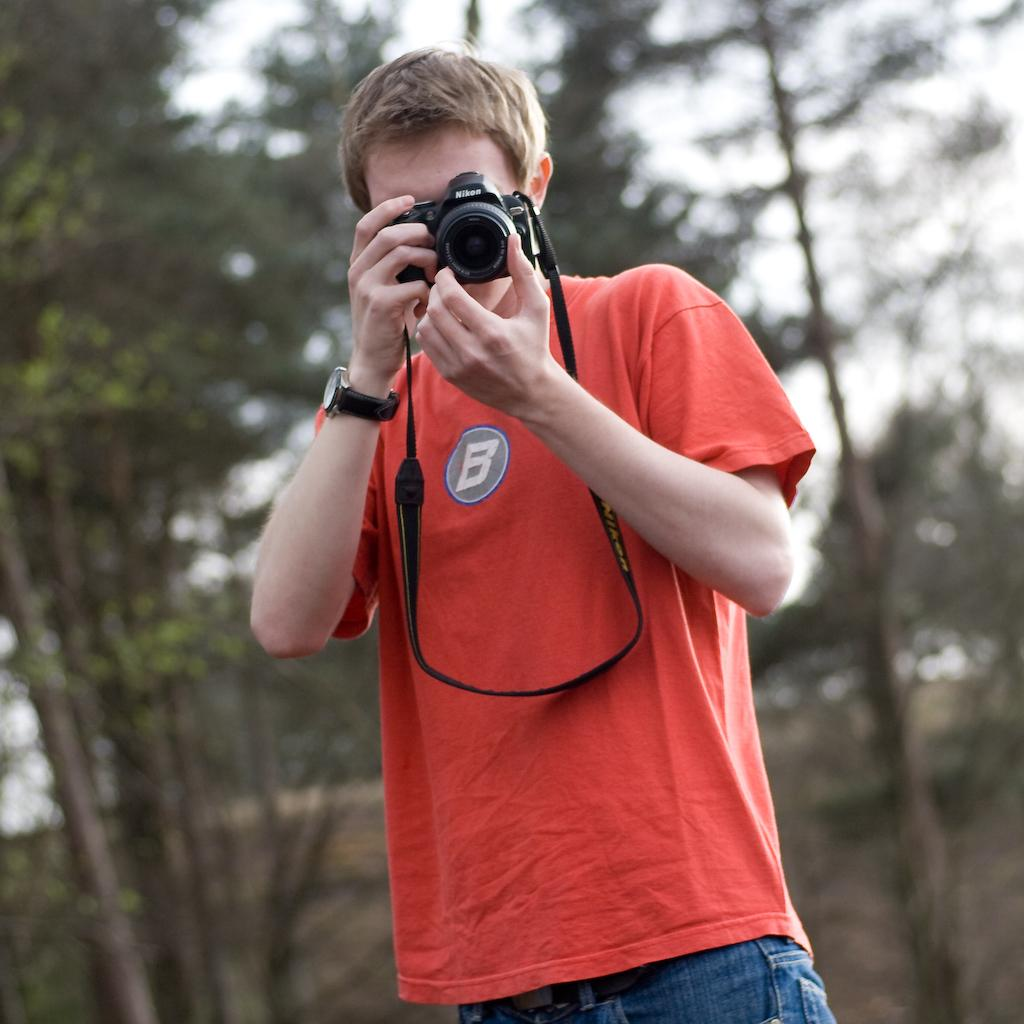Where was the image taken? The image was taken outside. Who is present in the image? There is a man in the image. What is the man wearing? The man is wearing an orange color shirt. What is the man holding in the image? The man is holding a camera. What accessory is the man wearing on his wrist? The man is wearing a watch. What can be seen in the background of the image? There are trees visible in the background of the image. What process is the man teaching at the school in the image? There is no school or teaching process present in the image; it features a man holding a camera outside. 